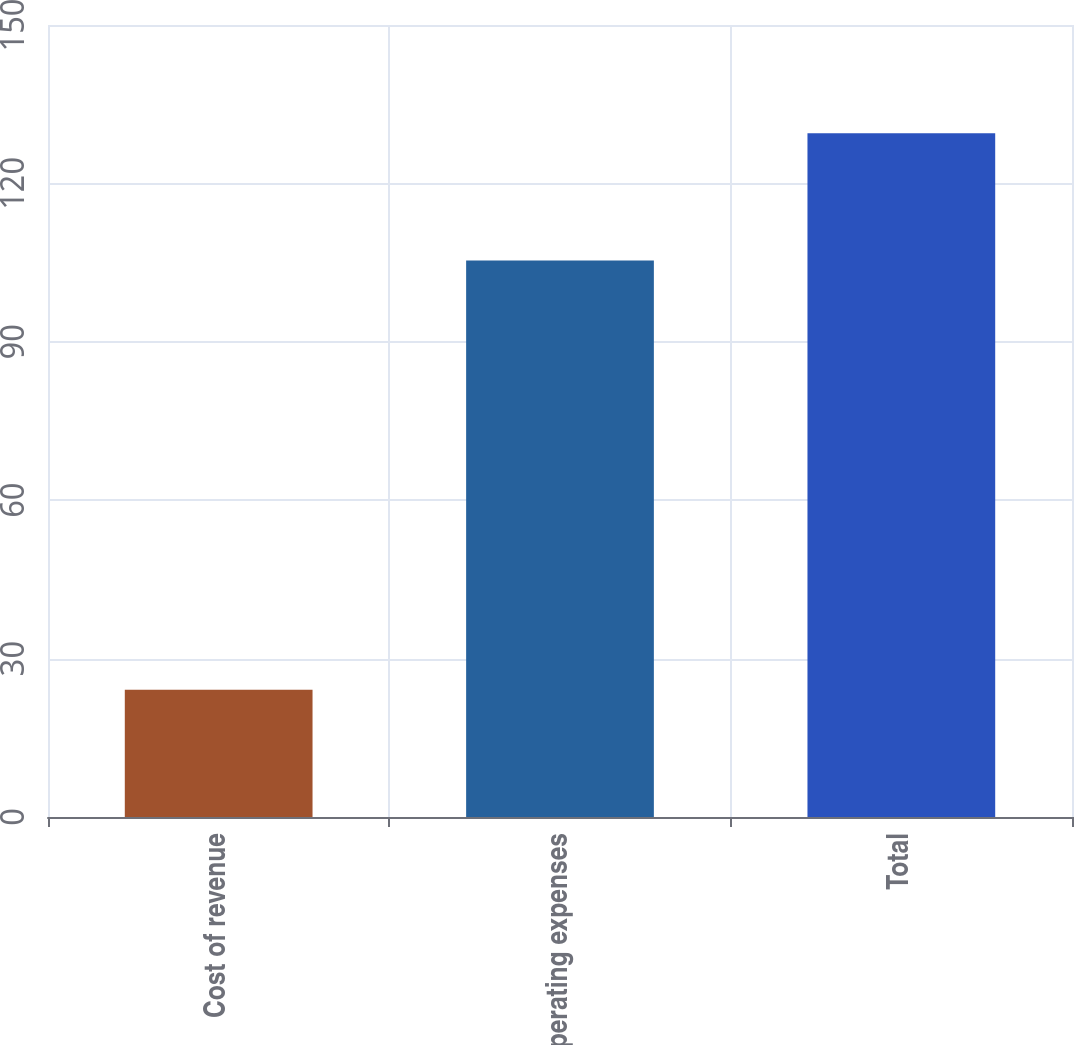<chart> <loc_0><loc_0><loc_500><loc_500><bar_chart><fcel>Cost of revenue<fcel>Operating expenses<fcel>Total<nl><fcel>24.1<fcel>105.4<fcel>129.5<nl></chart> 